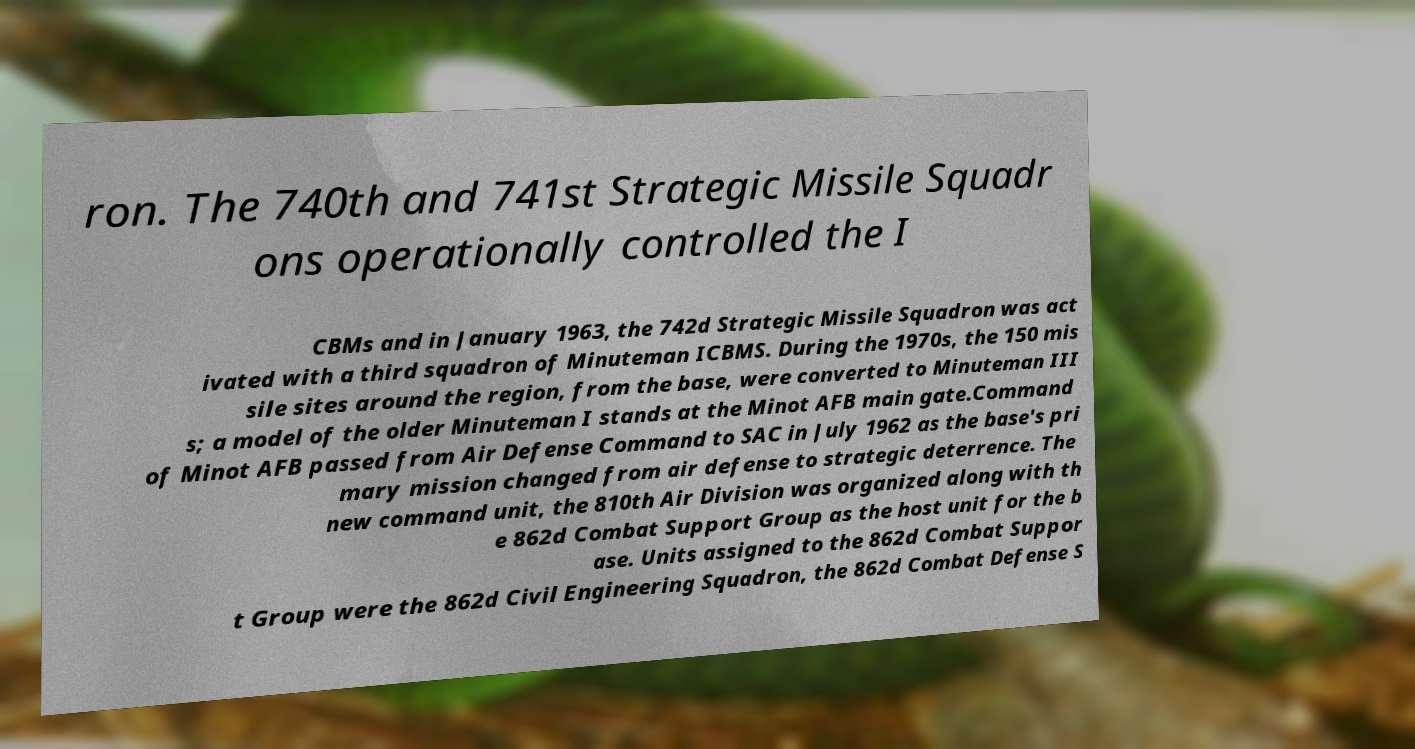I need the written content from this picture converted into text. Can you do that? ron. The 740th and 741st Strategic Missile Squadr ons operationally controlled the I CBMs and in January 1963, the 742d Strategic Missile Squadron was act ivated with a third squadron of Minuteman ICBMS. During the 1970s, the 150 mis sile sites around the region, from the base, were converted to Minuteman III s; a model of the older Minuteman I stands at the Minot AFB main gate.Command of Minot AFB passed from Air Defense Command to SAC in July 1962 as the base's pri mary mission changed from air defense to strategic deterrence. The new command unit, the 810th Air Division was organized along with th e 862d Combat Support Group as the host unit for the b ase. Units assigned to the 862d Combat Suppor t Group were the 862d Civil Engineering Squadron, the 862d Combat Defense S 